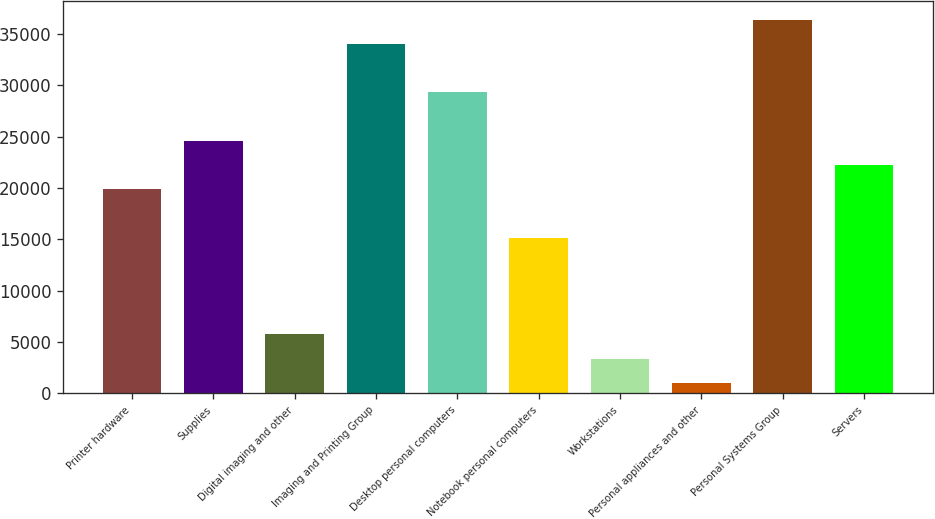<chart> <loc_0><loc_0><loc_500><loc_500><bar_chart><fcel>Printer hardware<fcel>Supplies<fcel>Digital imaging and other<fcel>Imaging and Printing Group<fcel>Desktop personal computers<fcel>Notebook personal computers<fcel>Workstations<fcel>Personal appliances and other<fcel>Personal Systems Group<fcel>Servers<nl><fcel>19900.4<fcel>24622<fcel>5735.6<fcel>34065.2<fcel>29343.6<fcel>15178.8<fcel>3374.8<fcel>1014<fcel>36426<fcel>22261.2<nl></chart> 